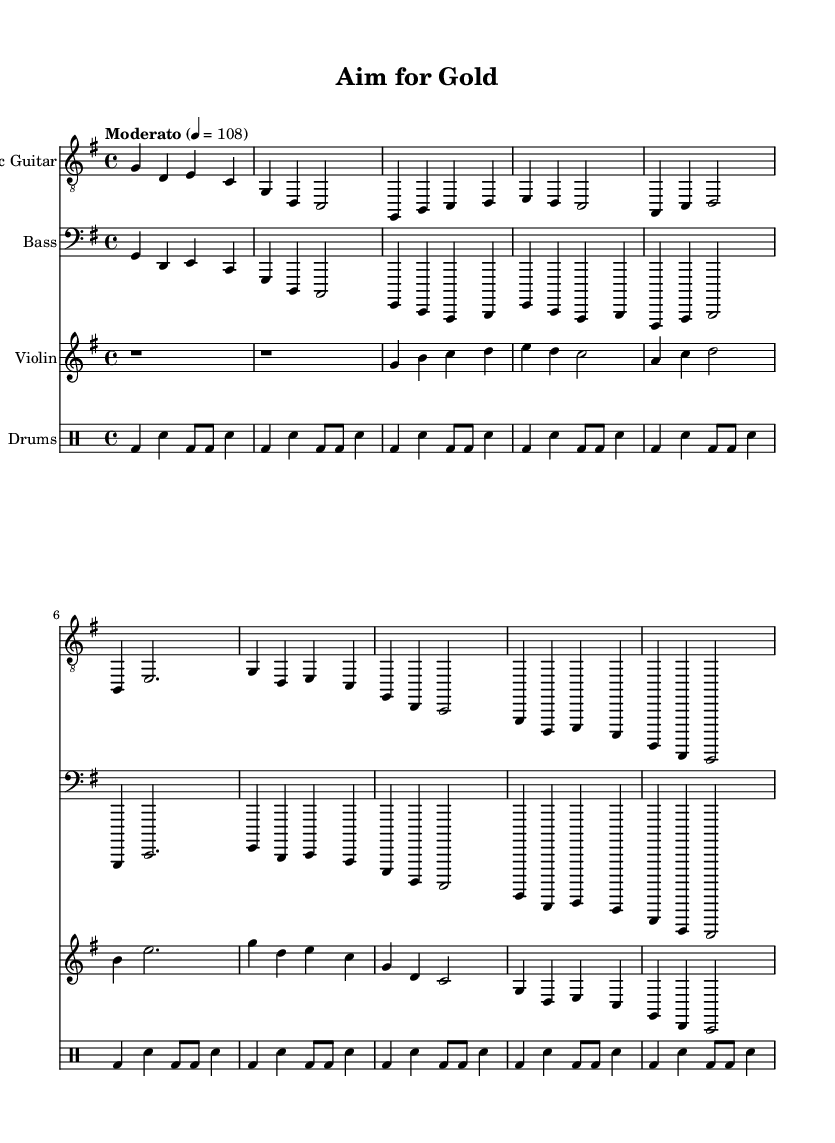What is the time signature of this music? The time signature is indicated in the music sheet as 4/4, which means there are four beats in a measure, and the quarter note gets one beat.
Answer: 4/4 What is the key signature of this piece? The key signature is G major, which has one sharp (F#), as indicated in the key signature section of the sheet music.
Answer: G major What tempo marking is used in the score? The tempo marking, written in the music sheet, is "Moderato" with a metronome marking of 108, indicating a moderate speed.
Answer: Moderato How many measures are in the Verse 1 section? The Verse 1 section consists of three measures, as observed from the counting in the written music lines for that section.
Answer: 3 What instrument plays the intro? The intro is played by the Electric Guitar, as it is the first instrument listed in the score that has a section labeled for it before the other instruments.
Answer: Electric Guitar Which instruments are used in this piece? The piece includes Electric Guitar, Bass, Violin, and Drums, as listed in the score with indicated staff for each instrument.
Answer: Electric Guitar, Bass, Violin, Drums What rhythmic pattern is associated with the drums throughout the piece? The drums follow a basic rock beat pattern throughout, consisting of bass drums on the beats and snare on the off-beats as shown in the drummode section.
Answer: Basic rock beat 